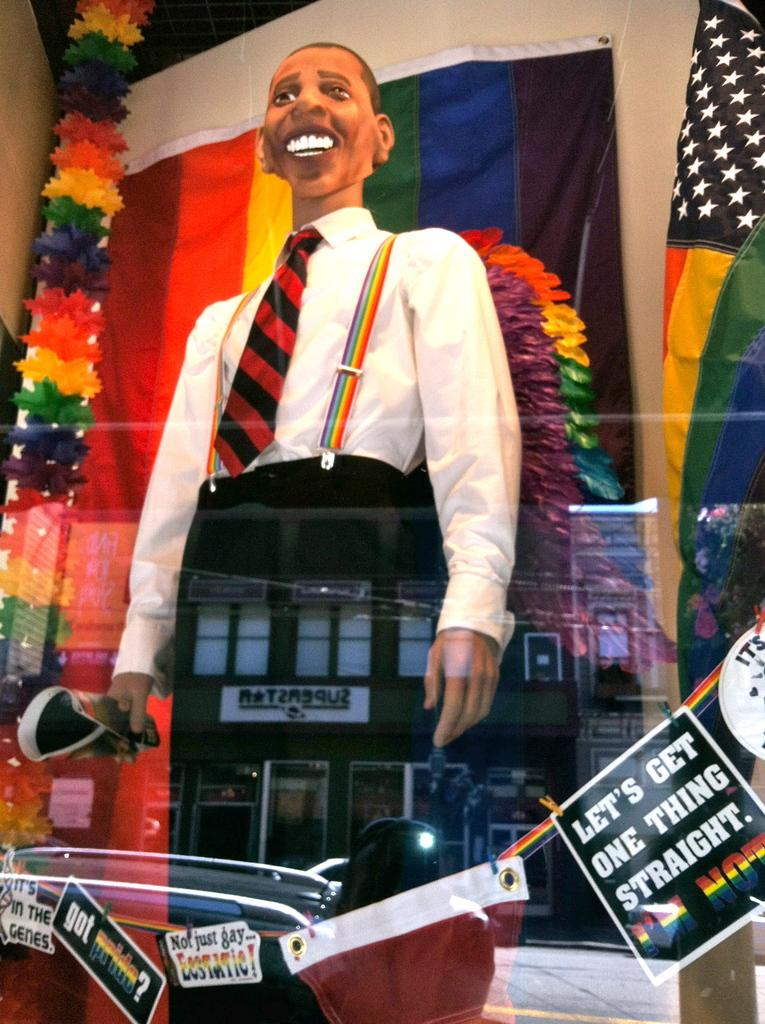What is the main subject of the image? There is a statue of a man in the image. What is the man holding in the image? The man is holding a poster in the image. Are there any other posters visible in the image? Yes, there are posters in the image. What type of material can be seen in the image? Cloth is visible in the image. What else can be found in the image? There are objects in the image. What can be seen in the background of the image? There are flags, a wall, and decorative items in the background of the image. What type of seed is being planted in the field shown in the image? There is no field or seed present in the image; it features a statue of a man holding a poster. 